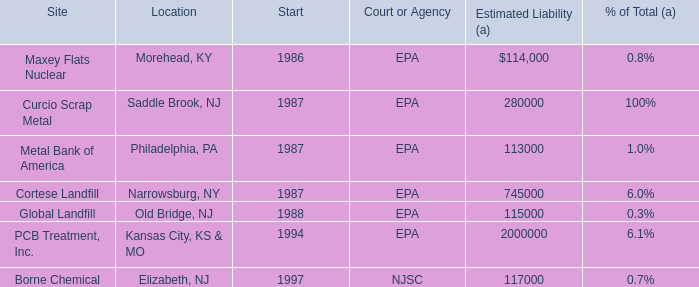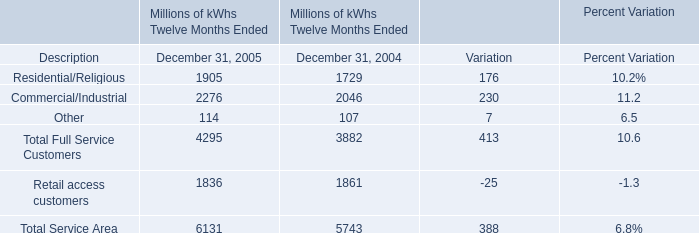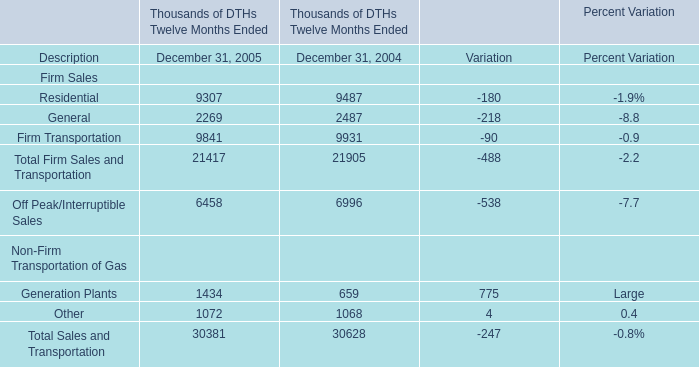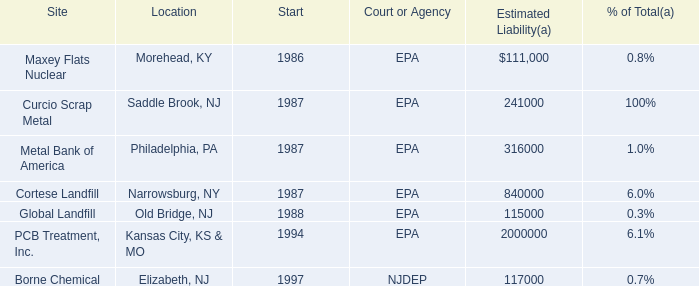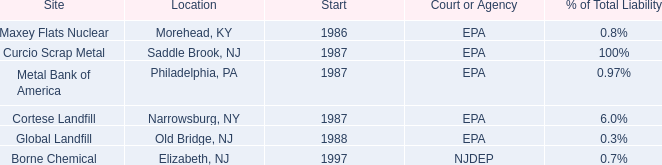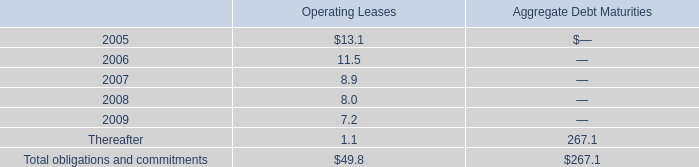In the year with lowest amount of Residential, what's the increasing rate of General? 
Computations: ((2269 - 2487) / 2487)
Answer: -0.08766. 